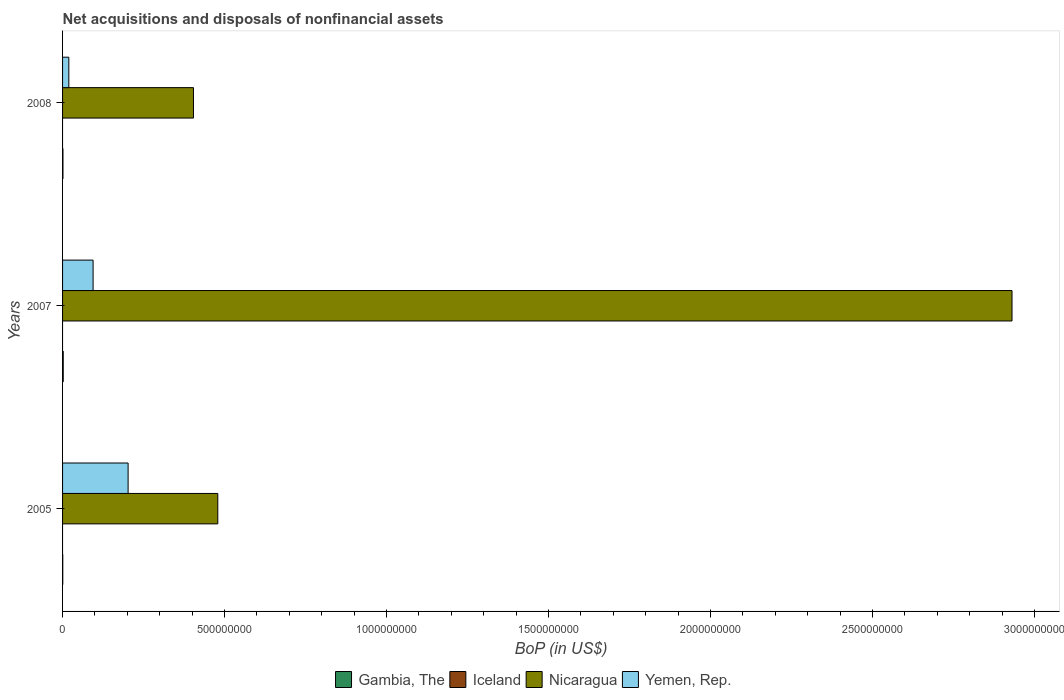How many groups of bars are there?
Offer a very short reply. 3. Are the number of bars per tick equal to the number of legend labels?
Provide a short and direct response. No. How many bars are there on the 2nd tick from the top?
Provide a succinct answer. 3. How many bars are there on the 1st tick from the bottom?
Provide a succinct answer. 3. What is the label of the 3rd group of bars from the top?
Ensure brevity in your answer.  2005. In how many cases, is the number of bars for a given year not equal to the number of legend labels?
Offer a terse response. 3. What is the Balance of Payments in Yemen, Rep. in 2008?
Offer a terse response. 1.93e+07. Across all years, what is the maximum Balance of Payments in Nicaragua?
Give a very brief answer. 2.93e+09. Across all years, what is the minimum Balance of Payments in Yemen, Rep.?
Make the answer very short. 1.93e+07. What is the total Balance of Payments in Nicaragua in the graph?
Your answer should be very brief. 3.81e+09. What is the difference between the Balance of Payments in Nicaragua in 2007 and that in 2008?
Provide a short and direct response. 2.53e+09. What is the difference between the Balance of Payments in Yemen, Rep. in 2008 and the Balance of Payments in Nicaragua in 2007?
Provide a short and direct response. -2.91e+09. What is the average Balance of Payments in Nicaragua per year?
Your response must be concise. 1.27e+09. In the year 2007, what is the difference between the Balance of Payments in Nicaragua and Balance of Payments in Yemen, Rep.?
Ensure brevity in your answer.  2.84e+09. What is the ratio of the Balance of Payments in Gambia, The in 2005 to that in 2007?
Offer a terse response. 0.29. What is the difference between the highest and the second highest Balance of Payments in Yemen, Rep.?
Your answer should be compact. 1.08e+08. What is the difference between the highest and the lowest Balance of Payments in Gambia, The?
Your response must be concise. 1.47e+06. Is the sum of the Balance of Payments in Yemen, Rep. in 2005 and 2007 greater than the maximum Balance of Payments in Gambia, The across all years?
Offer a terse response. Yes. Are all the bars in the graph horizontal?
Provide a short and direct response. Yes. How many years are there in the graph?
Provide a succinct answer. 3. What is the difference between two consecutive major ticks on the X-axis?
Your response must be concise. 5.00e+08. Are the values on the major ticks of X-axis written in scientific E-notation?
Provide a short and direct response. No. Where does the legend appear in the graph?
Provide a succinct answer. Bottom center. What is the title of the graph?
Your answer should be very brief. Net acquisitions and disposals of nonfinancial assets. Does "Curacao" appear as one of the legend labels in the graph?
Offer a very short reply. No. What is the label or title of the X-axis?
Your response must be concise. BoP (in US$). What is the BoP (in US$) of Gambia, The in 2005?
Provide a succinct answer. 5.98e+05. What is the BoP (in US$) in Nicaragua in 2005?
Provide a short and direct response. 4.79e+08. What is the BoP (in US$) in Yemen, Rep. in 2005?
Your answer should be compact. 2.02e+08. What is the BoP (in US$) of Gambia, The in 2007?
Offer a terse response. 2.07e+06. What is the BoP (in US$) of Nicaragua in 2007?
Your answer should be very brief. 2.93e+09. What is the BoP (in US$) in Yemen, Rep. in 2007?
Ensure brevity in your answer.  9.42e+07. What is the BoP (in US$) of Gambia, The in 2008?
Offer a very short reply. 1.17e+06. What is the BoP (in US$) in Iceland in 2008?
Keep it short and to the point. 0. What is the BoP (in US$) of Nicaragua in 2008?
Give a very brief answer. 4.04e+08. What is the BoP (in US$) in Yemen, Rep. in 2008?
Offer a very short reply. 1.93e+07. Across all years, what is the maximum BoP (in US$) in Gambia, The?
Ensure brevity in your answer.  2.07e+06. Across all years, what is the maximum BoP (in US$) of Nicaragua?
Keep it short and to the point. 2.93e+09. Across all years, what is the maximum BoP (in US$) of Yemen, Rep.?
Offer a terse response. 2.02e+08. Across all years, what is the minimum BoP (in US$) of Gambia, The?
Keep it short and to the point. 5.98e+05. Across all years, what is the minimum BoP (in US$) in Nicaragua?
Offer a terse response. 4.04e+08. Across all years, what is the minimum BoP (in US$) in Yemen, Rep.?
Offer a terse response. 1.93e+07. What is the total BoP (in US$) of Gambia, The in the graph?
Ensure brevity in your answer.  3.84e+06. What is the total BoP (in US$) in Iceland in the graph?
Give a very brief answer. 0. What is the total BoP (in US$) of Nicaragua in the graph?
Your response must be concise. 3.81e+09. What is the total BoP (in US$) of Yemen, Rep. in the graph?
Ensure brevity in your answer.  3.16e+08. What is the difference between the BoP (in US$) of Gambia, The in 2005 and that in 2007?
Keep it short and to the point. -1.47e+06. What is the difference between the BoP (in US$) of Nicaragua in 2005 and that in 2007?
Ensure brevity in your answer.  -2.45e+09. What is the difference between the BoP (in US$) in Yemen, Rep. in 2005 and that in 2007?
Offer a very short reply. 1.08e+08. What is the difference between the BoP (in US$) in Gambia, The in 2005 and that in 2008?
Ensure brevity in your answer.  -5.74e+05. What is the difference between the BoP (in US$) of Nicaragua in 2005 and that in 2008?
Your answer should be compact. 7.51e+07. What is the difference between the BoP (in US$) in Yemen, Rep. in 2005 and that in 2008?
Your answer should be very brief. 1.83e+08. What is the difference between the BoP (in US$) of Gambia, The in 2007 and that in 2008?
Provide a short and direct response. 8.96e+05. What is the difference between the BoP (in US$) of Nicaragua in 2007 and that in 2008?
Offer a terse response. 2.53e+09. What is the difference between the BoP (in US$) in Yemen, Rep. in 2007 and that in 2008?
Your answer should be compact. 7.49e+07. What is the difference between the BoP (in US$) in Gambia, The in 2005 and the BoP (in US$) in Nicaragua in 2007?
Provide a succinct answer. -2.93e+09. What is the difference between the BoP (in US$) in Gambia, The in 2005 and the BoP (in US$) in Yemen, Rep. in 2007?
Keep it short and to the point. -9.36e+07. What is the difference between the BoP (in US$) of Nicaragua in 2005 and the BoP (in US$) of Yemen, Rep. in 2007?
Offer a very short reply. 3.85e+08. What is the difference between the BoP (in US$) of Gambia, The in 2005 and the BoP (in US$) of Nicaragua in 2008?
Your response must be concise. -4.03e+08. What is the difference between the BoP (in US$) of Gambia, The in 2005 and the BoP (in US$) of Yemen, Rep. in 2008?
Your answer should be very brief. -1.87e+07. What is the difference between the BoP (in US$) in Nicaragua in 2005 and the BoP (in US$) in Yemen, Rep. in 2008?
Your response must be concise. 4.60e+08. What is the difference between the BoP (in US$) in Gambia, The in 2007 and the BoP (in US$) in Nicaragua in 2008?
Your response must be concise. -4.02e+08. What is the difference between the BoP (in US$) of Gambia, The in 2007 and the BoP (in US$) of Yemen, Rep. in 2008?
Make the answer very short. -1.73e+07. What is the difference between the BoP (in US$) in Nicaragua in 2007 and the BoP (in US$) in Yemen, Rep. in 2008?
Provide a short and direct response. 2.91e+09. What is the average BoP (in US$) of Gambia, The per year?
Offer a very short reply. 1.28e+06. What is the average BoP (in US$) in Nicaragua per year?
Provide a succinct answer. 1.27e+09. What is the average BoP (in US$) in Yemen, Rep. per year?
Your answer should be very brief. 1.05e+08. In the year 2005, what is the difference between the BoP (in US$) in Gambia, The and BoP (in US$) in Nicaragua?
Offer a very short reply. -4.79e+08. In the year 2005, what is the difference between the BoP (in US$) of Gambia, The and BoP (in US$) of Yemen, Rep.?
Offer a very short reply. -2.02e+08. In the year 2005, what is the difference between the BoP (in US$) of Nicaragua and BoP (in US$) of Yemen, Rep.?
Provide a short and direct response. 2.77e+08. In the year 2007, what is the difference between the BoP (in US$) of Gambia, The and BoP (in US$) of Nicaragua?
Offer a terse response. -2.93e+09. In the year 2007, what is the difference between the BoP (in US$) of Gambia, The and BoP (in US$) of Yemen, Rep.?
Offer a terse response. -9.22e+07. In the year 2007, what is the difference between the BoP (in US$) in Nicaragua and BoP (in US$) in Yemen, Rep.?
Your response must be concise. 2.84e+09. In the year 2008, what is the difference between the BoP (in US$) in Gambia, The and BoP (in US$) in Nicaragua?
Offer a very short reply. -4.03e+08. In the year 2008, what is the difference between the BoP (in US$) of Gambia, The and BoP (in US$) of Yemen, Rep.?
Your answer should be very brief. -1.82e+07. In the year 2008, what is the difference between the BoP (in US$) of Nicaragua and BoP (in US$) of Yemen, Rep.?
Make the answer very short. 3.85e+08. What is the ratio of the BoP (in US$) of Gambia, The in 2005 to that in 2007?
Give a very brief answer. 0.29. What is the ratio of the BoP (in US$) in Nicaragua in 2005 to that in 2007?
Your response must be concise. 0.16. What is the ratio of the BoP (in US$) of Yemen, Rep. in 2005 to that in 2007?
Offer a terse response. 2.15. What is the ratio of the BoP (in US$) of Gambia, The in 2005 to that in 2008?
Your answer should be very brief. 0.51. What is the ratio of the BoP (in US$) of Nicaragua in 2005 to that in 2008?
Keep it short and to the point. 1.19. What is the ratio of the BoP (in US$) in Yemen, Rep. in 2005 to that in 2008?
Offer a terse response. 10.46. What is the ratio of the BoP (in US$) in Gambia, The in 2007 to that in 2008?
Provide a succinct answer. 1.76. What is the ratio of the BoP (in US$) in Nicaragua in 2007 to that in 2008?
Give a very brief answer. 7.25. What is the ratio of the BoP (in US$) in Yemen, Rep. in 2007 to that in 2008?
Provide a short and direct response. 4.87. What is the difference between the highest and the second highest BoP (in US$) in Gambia, The?
Provide a succinct answer. 8.96e+05. What is the difference between the highest and the second highest BoP (in US$) in Nicaragua?
Offer a very short reply. 2.45e+09. What is the difference between the highest and the second highest BoP (in US$) of Yemen, Rep.?
Your answer should be very brief. 1.08e+08. What is the difference between the highest and the lowest BoP (in US$) in Gambia, The?
Your answer should be very brief. 1.47e+06. What is the difference between the highest and the lowest BoP (in US$) in Nicaragua?
Make the answer very short. 2.53e+09. What is the difference between the highest and the lowest BoP (in US$) of Yemen, Rep.?
Offer a very short reply. 1.83e+08. 